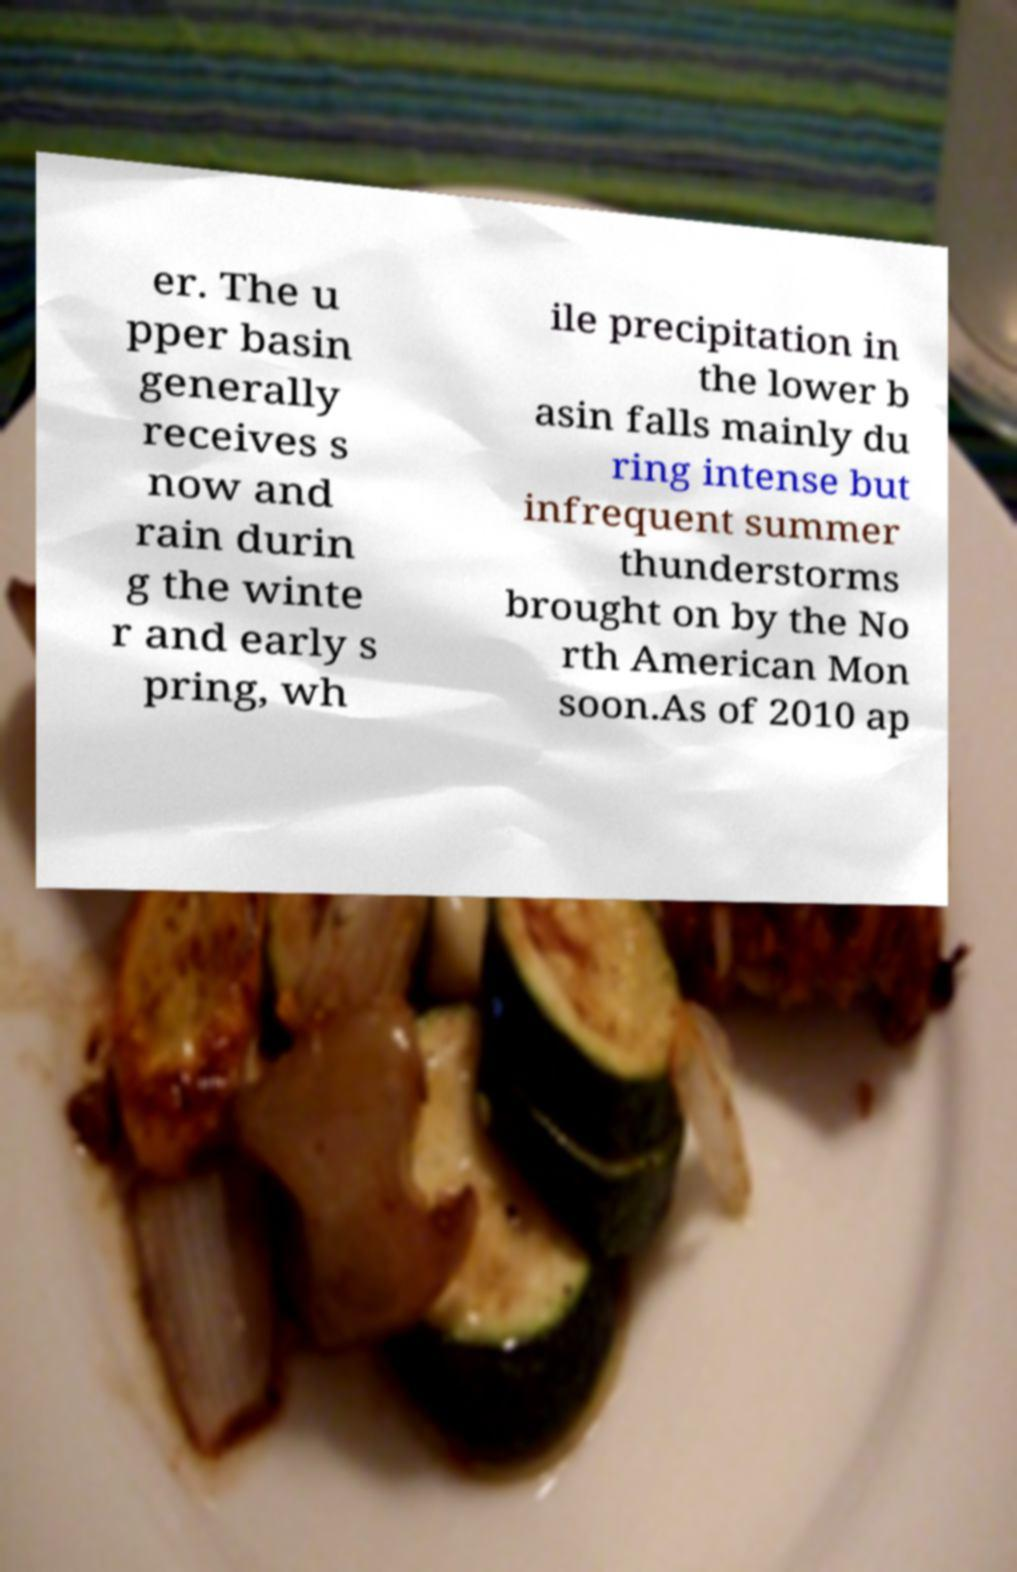For documentation purposes, I need the text within this image transcribed. Could you provide that? er. The u pper basin generally receives s now and rain durin g the winte r and early s pring, wh ile precipitation in the lower b asin falls mainly du ring intense but infrequent summer thunderstorms brought on by the No rth American Mon soon.As of 2010 ap 